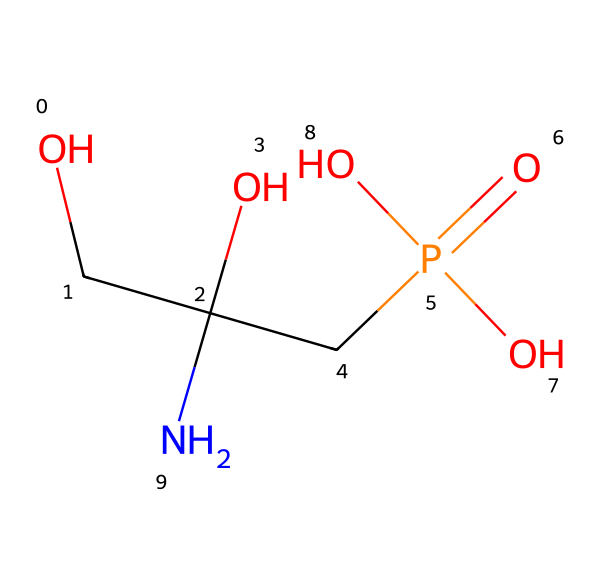What is the molecular formula of glyphosate? The SMILES representation can be interpreted to determine the number of each atom present. By breaking it down: C (carbon) appears 3 times, H (hydrogen) appears 8 times, N (nitrogen) appears once, O (oxygen) appears 4 times, and P (phosphorus) appears once. The molecular formula is constructed by combining these counts into the standard format.
Answer: C3H8N1O4P1 How many nitrogen atoms are in glyphosate? By examining the SMILES structure, the presence of 'N' indicates the nitrogen atoms. In glyphosate, there is one instance of 'N', confirming a total of one nitrogen atom.
Answer: 1 What is the functional group present in glyphosate? The SMILES representation reveals several functional groups, particularly the presence of a phosphate group (P=O and adjacent O's) and an amine group (the N connected to C). Both are important for glyphosate's activity as a herbicide.
Answer: phosphate and amine Identify one reason glyphosate is effective as a herbicide. The presence of the phosphonate structure allows glyphosate to disrupt the shikimic acid pathway, which is crucial for plant growth but absent in animals. This targeting mechanism is key for glyphosate's effectiveness.
Answer: disrupts plant metabolism What is the overall polarity of glyphosate, and why is it relevant? The glyphosate structure contains multiple polar functional groups (amino and acidic protons from the phosphate), increasing its solubility in water. This polarity aids in its uptake by plants and affects its environmental behavior.
Answer: polar How does the phosphorus atom influence glyphosate's function? The phosphorus atom is integral to the chemical’s phosphate group, which plays a critical role in the herbicide's mode of action by mimicking natural metabolites that interrupt plant growth. This mimicking is essential for glyphosate's herbicidal activity.
Answer: critical for herbicidal action 